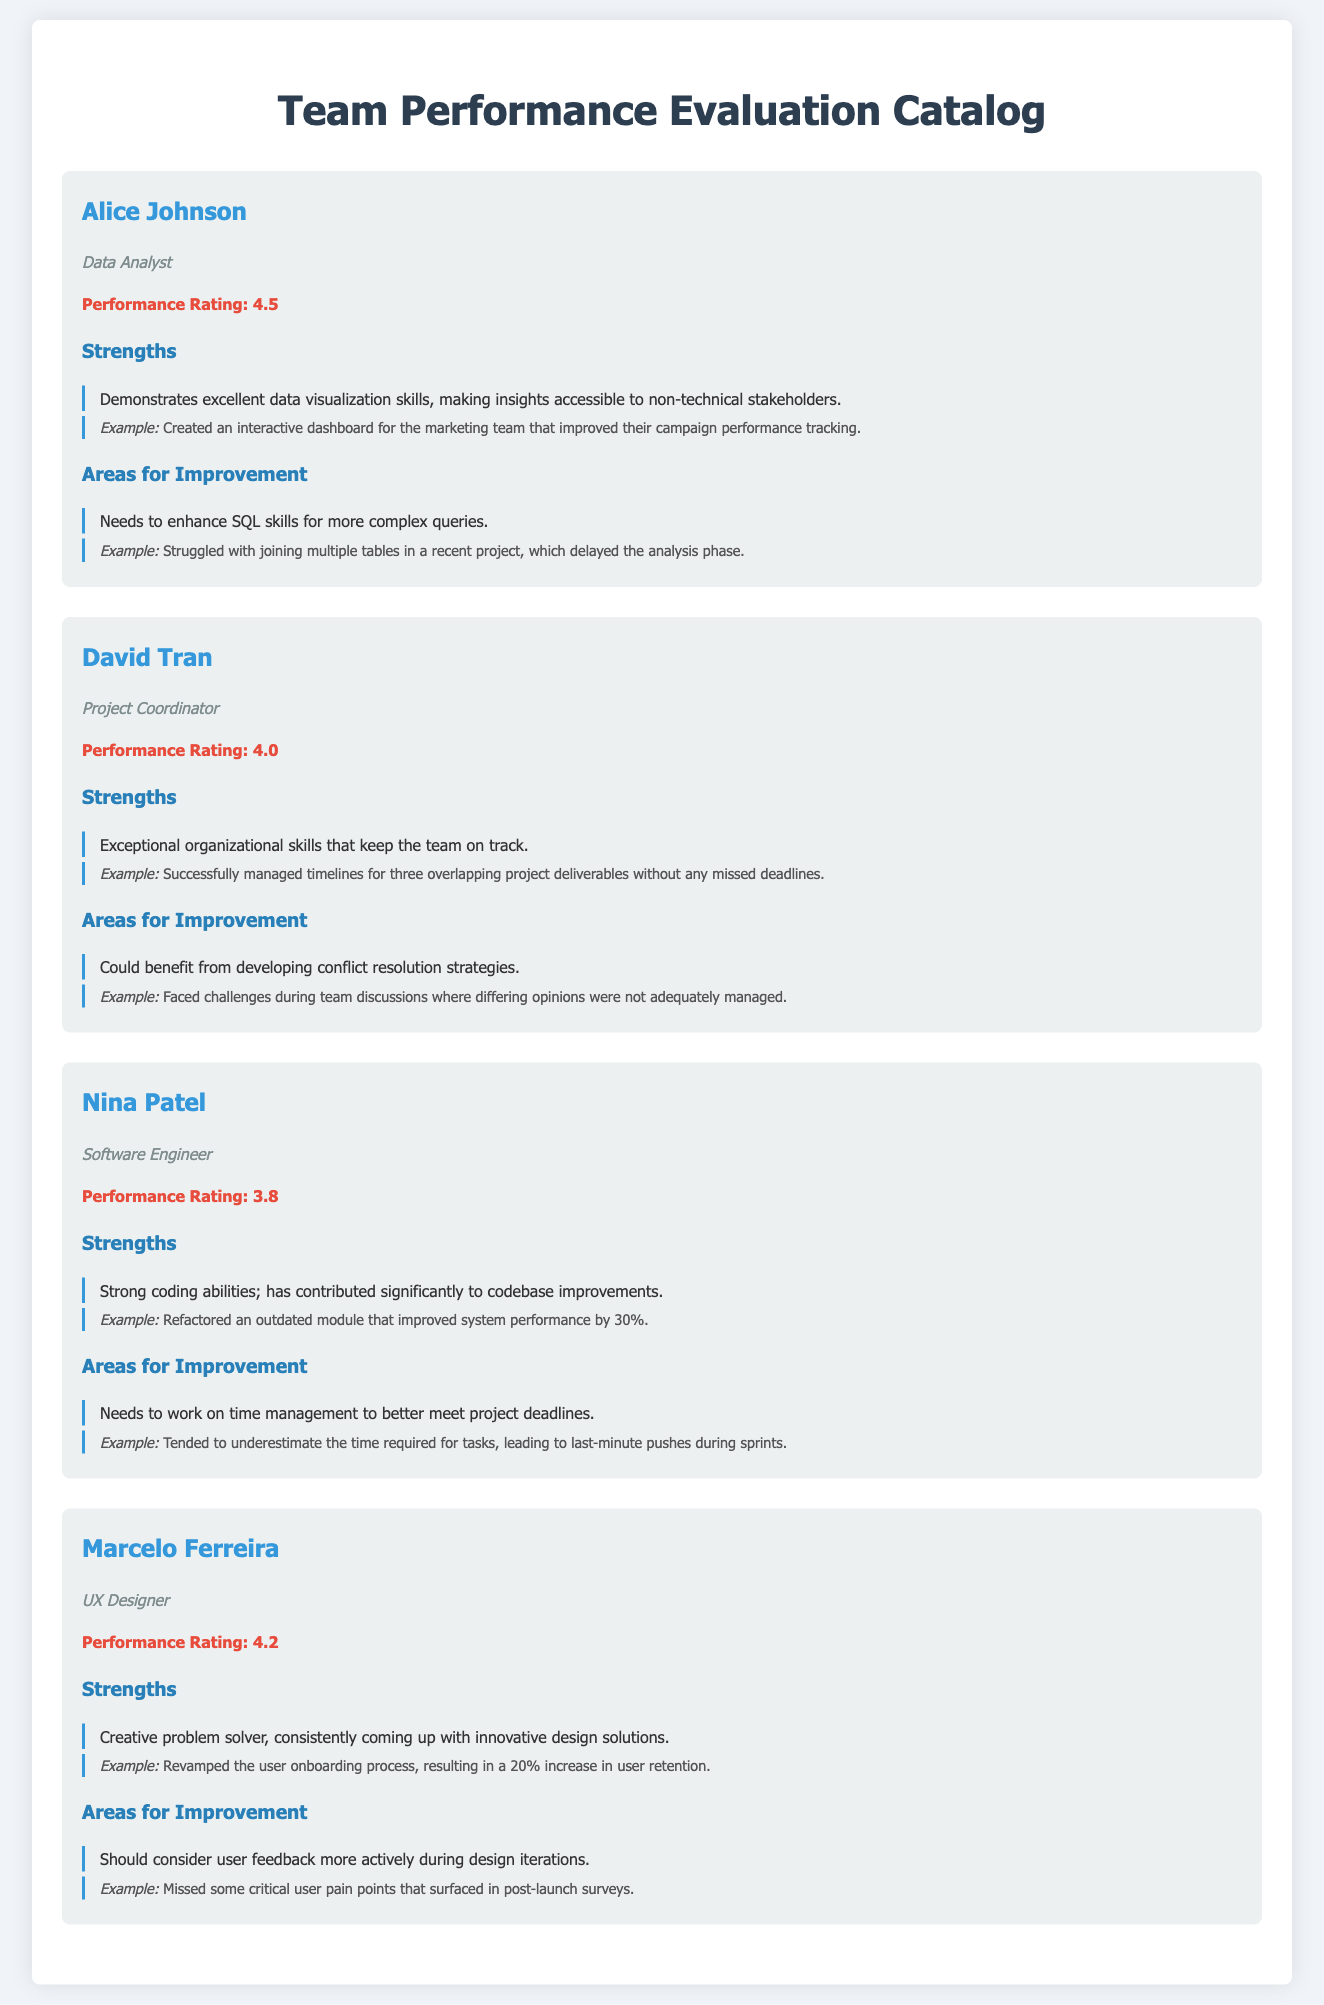What is Alice Johnson's role? Alice Johnson is identified as a Data Analyst in the document.
Answer: Data Analyst What was David Tran's performance rating? The document states David Tran's performance rating is 4.0.
Answer: 4.0 Which team member refactored an outdated module? The document mentions Nina Patel as the team member who refactored an outdated module.
Answer: Nina Patel What area does Marcelo Ferreira need to improve? Marcelo Ferreira should consider user feedback more actively during design iterations.
Answer: Consider user feedback What is the example given for Alice Johnson's strength? The example provided states that Alice created an interactive dashboard for the marketing team.
Answer: Created an interactive dashboard Who has exceptional organizational skills? David Tran is described as having exceptional organizational skills in the document.
Answer: David Tran What percentage increase in user retention is attributed to Marcelo Ferreira's work? The document specifies a 20% increase in user retention due to Marcelo Ferreira's design changes.
Answer: 20% Which team member struggles with time management? Nina Patel is indicated as needing to work on time management to meet deadlines better.
Answer: Nina Patel What is the strength highlighted for David Tran? David Tran's strength is his exceptional organizational skills that keep the team on track.
Answer: Exceptional organizational skills 